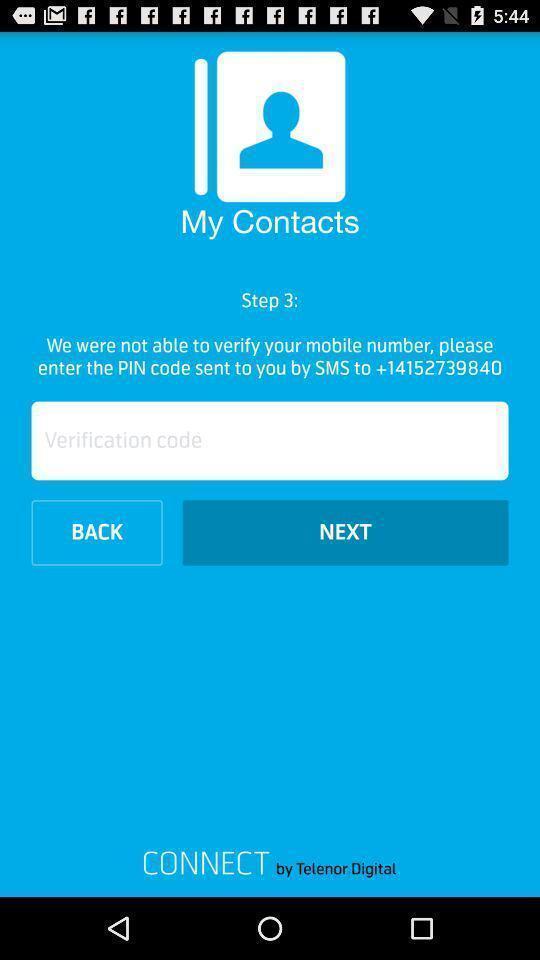Give me a narrative description of this picture. Welcome page for a contacts app. 